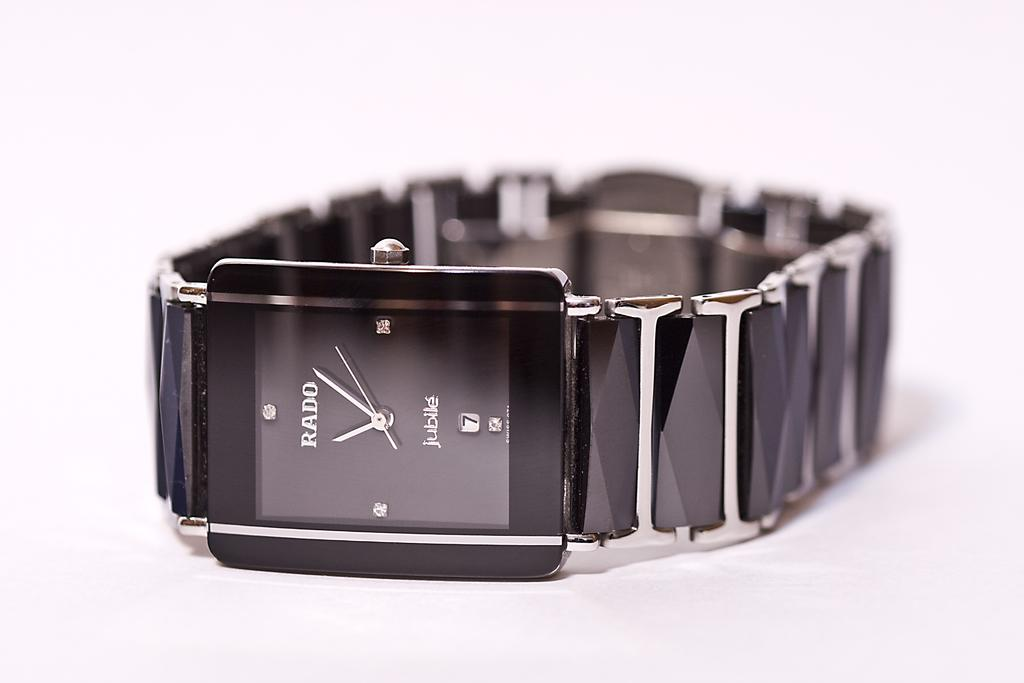<image>
Summarize the visual content of the image. A RADU jubille branded watch with black stone wrist band. 